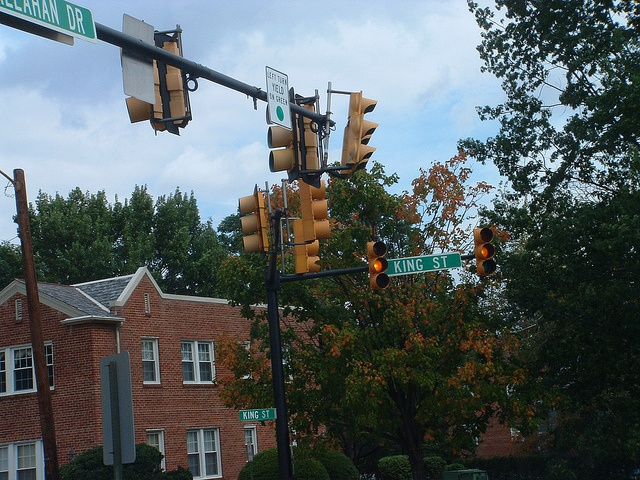Describe the objects in this image and their specific colors. I can see traffic light in teal, gray, tan, and black tones, traffic light in teal, maroon, brown, and gray tones, traffic light in teal, gray, and maroon tones, traffic light in teal, maroon, gray, and black tones, and traffic light in teal, black, gray, and maroon tones in this image. 